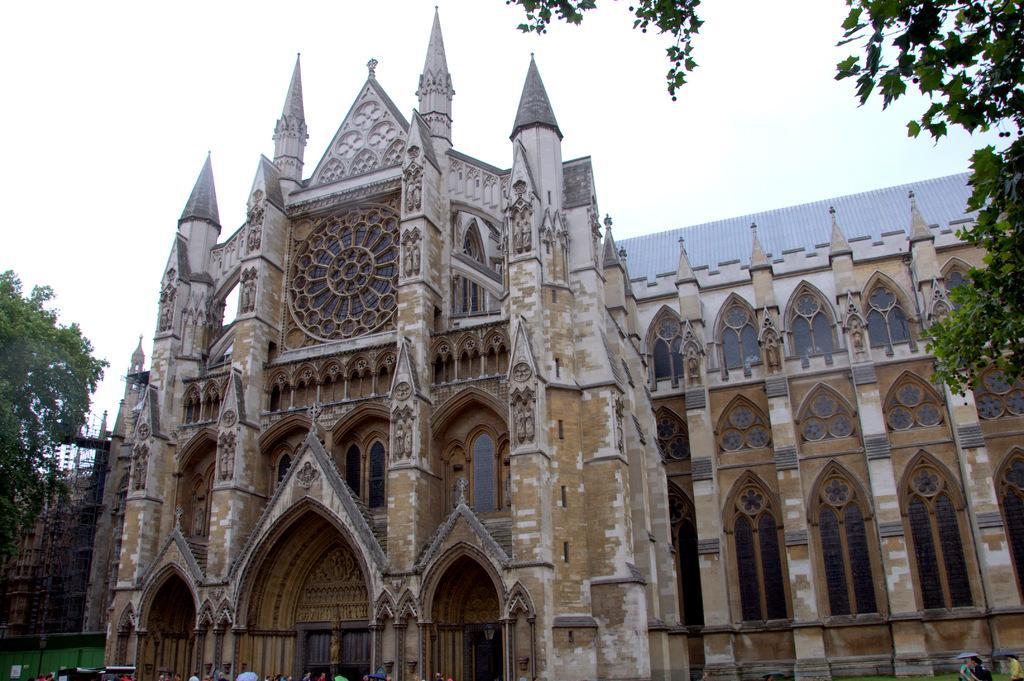Can you describe this image briefly? In this image I can see a building, windows, trees and few people. The sky is in white color. 